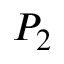<formula> <loc_0><loc_0><loc_500><loc_500>P _ { 2 }</formula> 